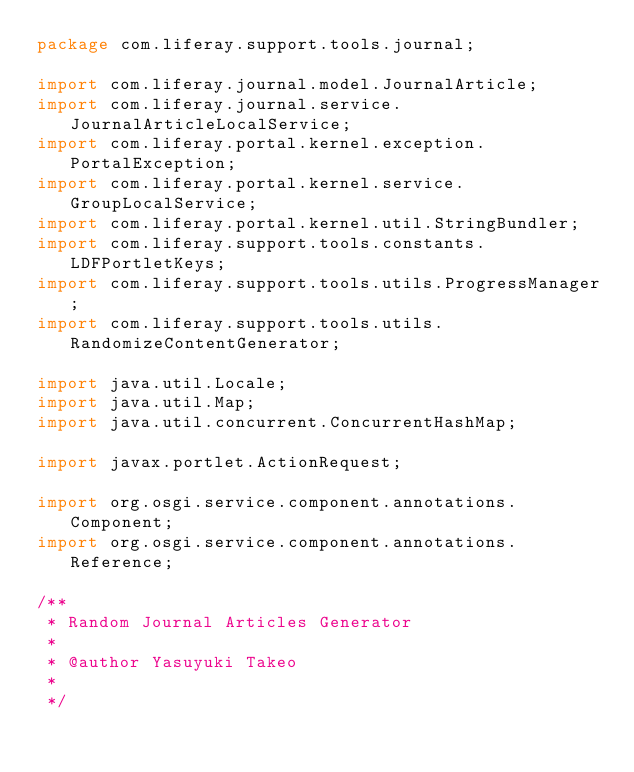<code> <loc_0><loc_0><loc_500><loc_500><_Java_>package com.liferay.support.tools.journal;

import com.liferay.journal.model.JournalArticle;
import com.liferay.journal.service.JournalArticleLocalService;
import com.liferay.portal.kernel.exception.PortalException;
import com.liferay.portal.kernel.service.GroupLocalService;
import com.liferay.portal.kernel.util.StringBundler;
import com.liferay.support.tools.constants.LDFPortletKeys;
import com.liferay.support.tools.utils.ProgressManager;
import com.liferay.support.tools.utils.RandomizeContentGenerator;

import java.util.Locale;
import java.util.Map;
import java.util.concurrent.ConcurrentHashMap;

import javax.portlet.ActionRequest;

import org.osgi.service.component.annotations.Component;
import org.osgi.service.component.annotations.Reference;

/**
 * Random Journal Articles Generator
 * 
 * @author Yasuyuki Takeo
 *
 */</code> 